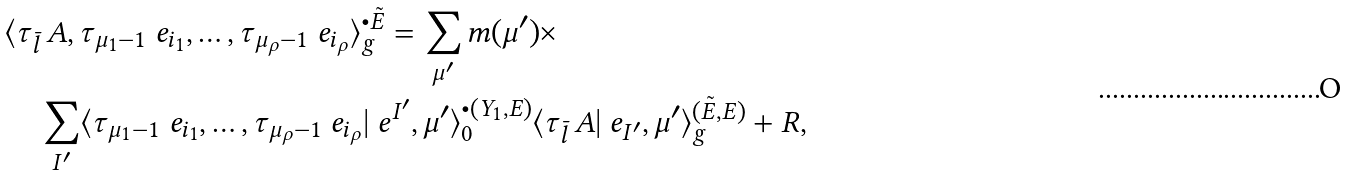Convert formula to latex. <formula><loc_0><loc_0><loc_500><loc_500>& \langle \tau _ { \bar { l } \, } A , \tau _ { \mu _ { 1 } - 1 } \ e _ { i _ { 1 } } , \dots , \tau _ { \mu _ { \rho } - 1 } \ e _ { i _ { \rho } } \rangle ^ { \bullet \tilde { E } } _ { g } = \sum _ { \mu ^ { \prime } } m ( \mu ^ { \prime } ) \times \\ & \quad \sum _ { I ^ { \prime } } \langle \tau _ { \mu _ { 1 } - 1 } \ e _ { i _ { 1 } } , \dots , \tau _ { \mu _ { \rho } - 1 } \ e _ { i _ { \rho } } | \ e ^ { I ^ { \prime } } , \mu ^ { \prime } \rangle ^ { \bullet ( Y _ { 1 } , E ) } _ { 0 } \langle \tau _ { \bar { l } \, } A | \ e _ { I ^ { \prime } } , \mu ^ { \prime } \rangle ^ { ( \tilde { E } , E ) } _ { g } + R ,</formula> 